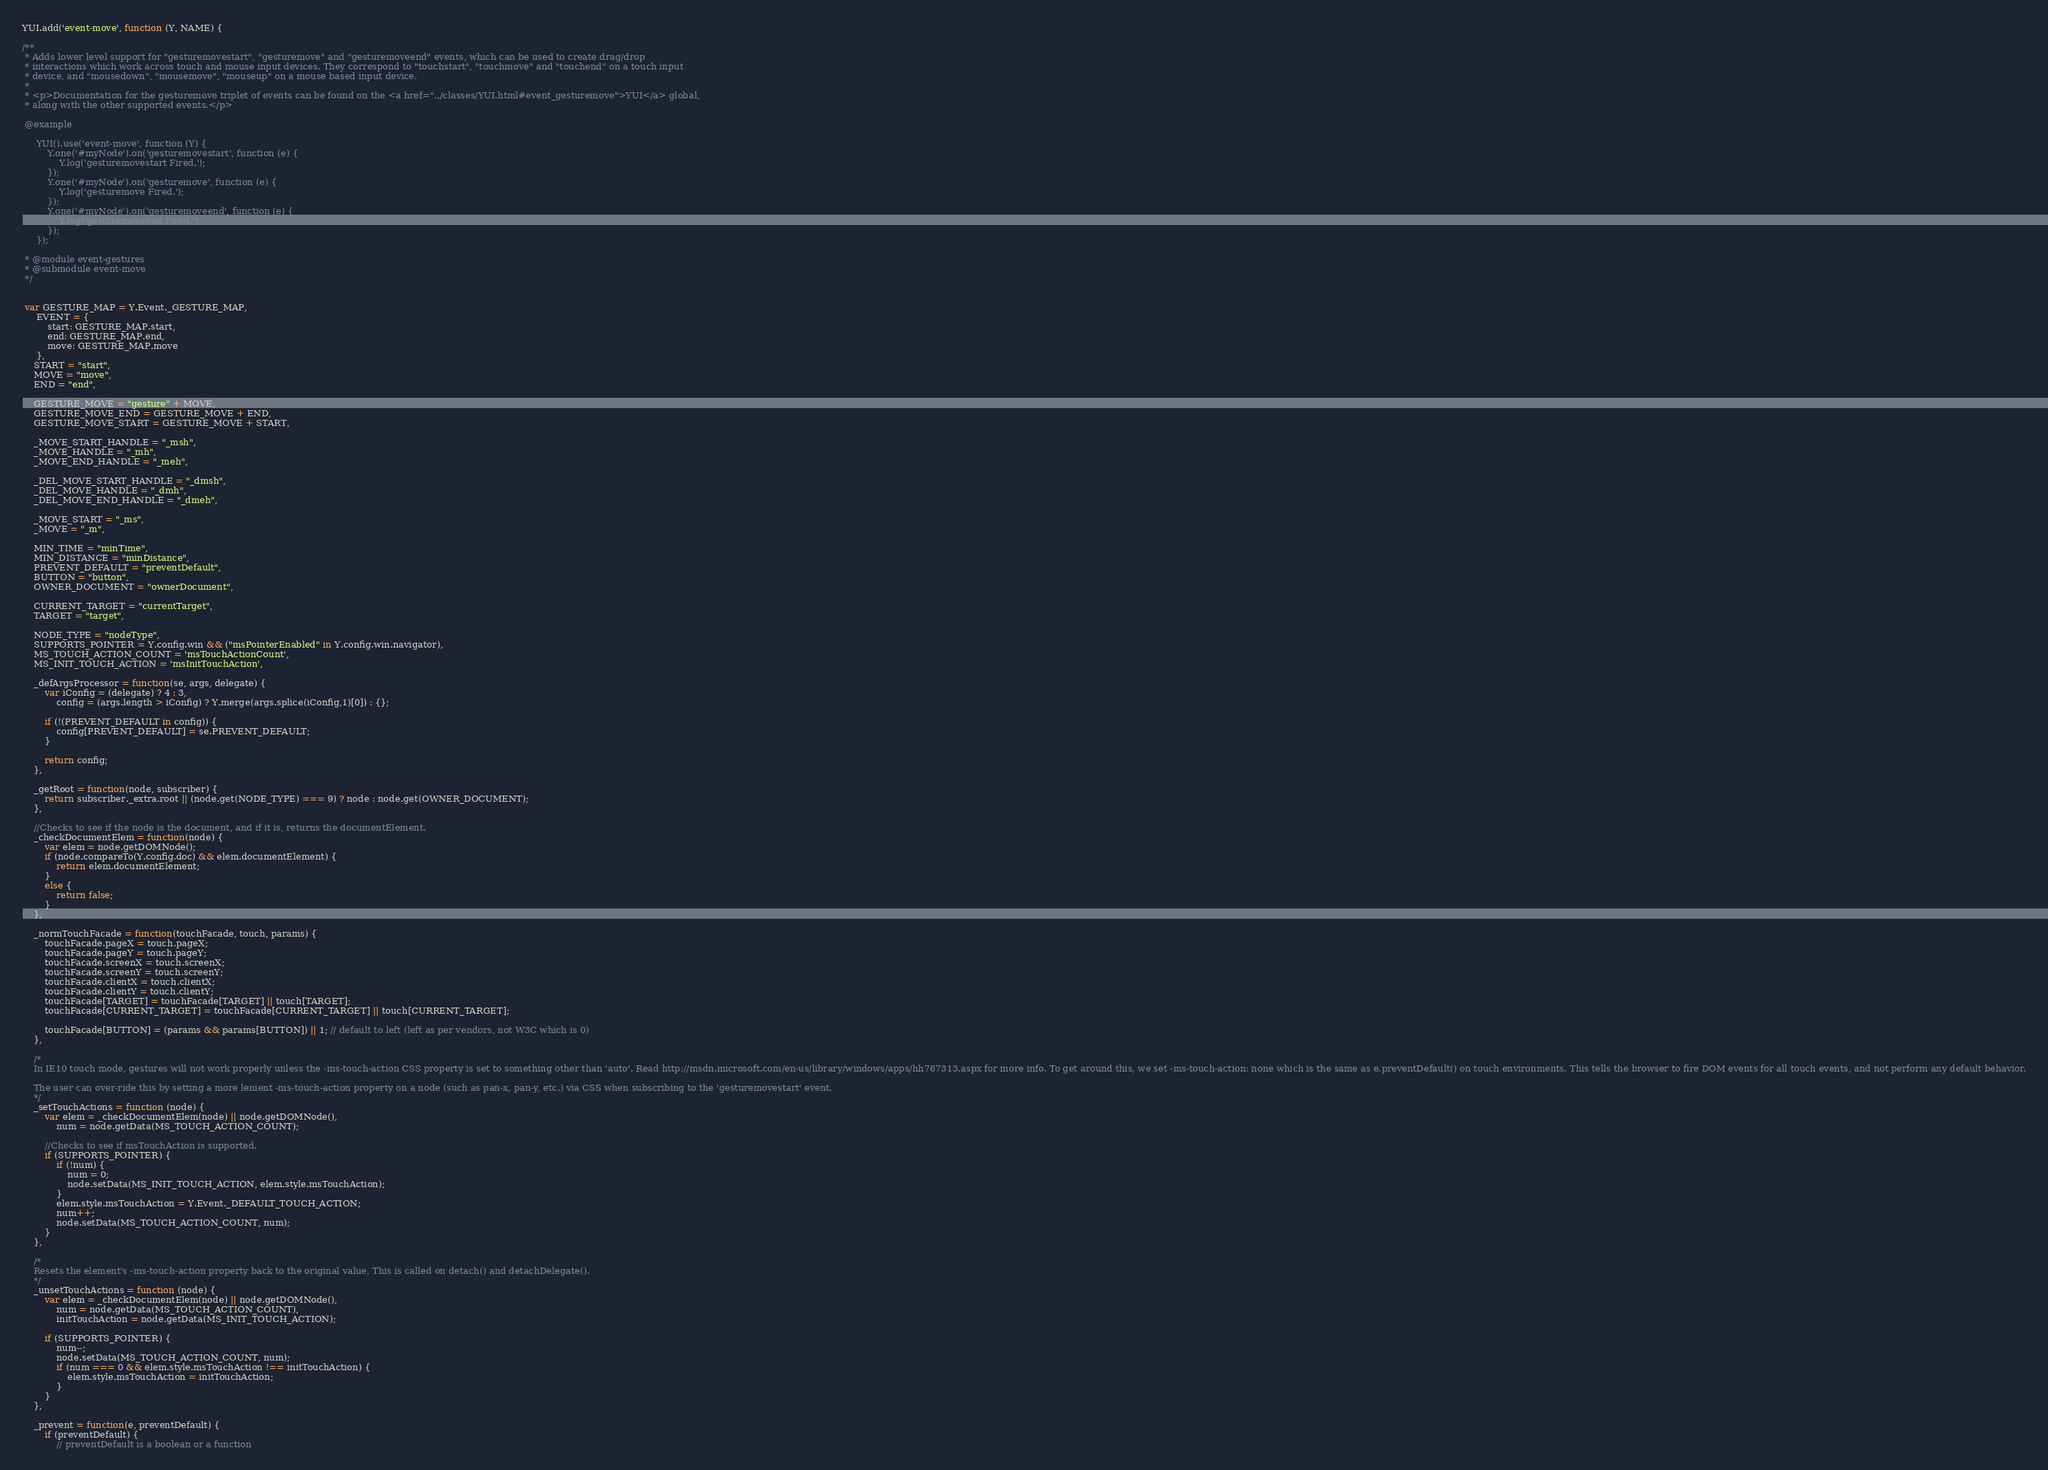<code> <loc_0><loc_0><loc_500><loc_500><_JavaScript_>YUI.add('event-move', function (Y, NAME) {

/**
 * Adds lower level support for "gesturemovestart", "gesturemove" and "gesturemoveend" events, which can be used to create drag/drop
 * interactions which work across touch and mouse input devices. They correspond to "touchstart", "touchmove" and "touchend" on a touch input
 * device, and "mousedown", "mousemove", "mouseup" on a mouse based input device.
 *
 * <p>Documentation for the gesturemove triplet of events can be found on the <a href="../classes/YUI.html#event_gesturemove">YUI</a> global,
 * along with the other supported events.</p>

 @example

     YUI().use('event-move', function (Y) {
         Y.one('#myNode').on('gesturemovestart', function (e) {
             Y.log('gesturemovestart Fired.');
         });
         Y.one('#myNode').on('gesturemove', function (e) {
             Y.log('gesturemove Fired.');
         });
         Y.one('#myNode').on('gesturemoveend', function (e) {
             Y.log('gesturemoveend Fired.');
         });
     });

 * @module event-gestures
 * @submodule event-move
 */


 var GESTURE_MAP = Y.Event._GESTURE_MAP,
     EVENT = {
         start: GESTURE_MAP.start,
         end: GESTURE_MAP.end,
         move: GESTURE_MAP.move
     },
    START = "start",
    MOVE = "move",
    END = "end",

    GESTURE_MOVE = "gesture" + MOVE,
    GESTURE_MOVE_END = GESTURE_MOVE + END,
    GESTURE_MOVE_START = GESTURE_MOVE + START,

    _MOVE_START_HANDLE = "_msh",
    _MOVE_HANDLE = "_mh",
    _MOVE_END_HANDLE = "_meh",

    _DEL_MOVE_START_HANDLE = "_dmsh",
    _DEL_MOVE_HANDLE = "_dmh",
    _DEL_MOVE_END_HANDLE = "_dmeh",

    _MOVE_START = "_ms",
    _MOVE = "_m",

    MIN_TIME = "minTime",
    MIN_DISTANCE = "minDistance",
    PREVENT_DEFAULT = "preventDefault",
    BUTTON = "button",
    OWNER_DOCUMENT = "ownerDocument",

    CURRENT_TARGET = "currentTarget",
    TARGET = "target",

    NODE_TYPE = "nodeType",
    SUPPORTS_POINTER = Y.config.win && ("msPointerEnabled" in Y.config.win.navigator),
    MS_TOUCH_ACTION_COUNT = 'msTouchActionCount',
    MS_INIT_TOUCH_ACTION = 'msInitTouchAction',

    _defArgsProcessor = function(se, args, delegate) {
        var iConfig = (delegate) ? 4 : 3,
            config = (args.length > iConfig) ? Y.merge(args.splice(iConfig,1)[0]) : {};

        if (!(PREVENT_DEFAULT in config)) {
            config[PREVENT_DEFAULT] = se.PREVENT_DEFAULT;
        }

        return config;
    },

    _getRoot = function(node, subscriber) {
        return subscriber._extra.root || (node.get(NODE_TYPE) === 9) ? node : node.get(OWNER_DOCUMENT);
    },

    //Checks to see if the node is the document, and if it is, returns the documentElement.
    _checkDocumentElem = function(node) {
        var elem = node.getDOMNode();
        if (node.compareTo(Y.config.doc) && elem.documentElement) {
            return elem.documentElement;
        }
        else {
            return false;
        }
    },

    _normTouchFacade = function(touchFacade, touch, params) {
        touchFacade.pageX = touch.pageX;
        touchFacade.pageY = touch.pageY;
        touchFacade.screenX = touch.screenX;
        touchFacade.screenY = touch.screenY;
        touchFacade.clientX = touch.clientX;
        touchFacade.clientY = touch.clientY;
        touchFacade[TARGET] = touchFacade[TARGET] || touch[TARGET];
        touchFacade[CURRENT_TARGET] = touchFacade[CURRENT_TARGET] || touch[CURRENT_TARGET];

        touchFacade[BUTTON] = (params && params[BUTTON]) || 1; // default to left (left as per vendors, not W3C which is 0)
    },

    /*
    In IE10 touch mode, gestures will not work properly unless the -ms-touch-action CSS property is set to something other than 'auto'. Read http://msdn.microsoft.com/en-us/library/windows/apps/hh767313.aspx for more info. To get around this, we set -ms-touch-action: none which is the same as e.preventDefault() on touch environments. This tells the browser to fire DOM events for all touch events, and not perform any default behavior.

    The user can over-ride this by setting a more lenient -ms-touch-action property on a node (such as pan-x, pan-y, etc.) via CSS when subscribing to the 'gesturemovestart' event.
    */
    _setTouchActions = function (node) {
        var elem = _checkDocumentElem(node) || node.getDOMNode(),
            num = node.getData(MS_TOUCH_ACTION_COUNT);

        //Checks to see if msTouchAction is supported.
        if (SUPPORTS_POINTER) {
            if (!num) {
                num = 0;
                node.setData(MS_INIT_TOUCH_ACTION, elem.style.msTouchAction);
            }
            elem.style.msTouchAction = Y.Event._DEFAULT_TOUCH_ACTION;
            num++;
            node.setData(MS_TOUCH_ACTION_COUNT, num);
        }
    },

    /*
    Resets the element's -ms-touch-action property back to the original value, This is called on detach() and detachDelegate().
    */
    _unsetTouchActions = function (node) {
        var elem = _checkDocumentElem(node) || node.getDOMNode(),
            num = node.getData(MS_TOUCH_ACTION_COUNT),
            initTouchAction = node.getData(MS_INIT_TOUCH_ACTION);

        if (SUPPORTS_POINTER) {
            num--;
            node.setData(MS_TOUCH_ACTION_COUNT, num);
            if (num === 0 && elem.style.msTouchAction !== initTouchAction) {
                elem.style.msTouchAction = initTouchAction;
            }
        }
    },

    _prevent = function(e, preventDefault) {
        if (preventDefault) {
            // preventDefault is a boolean or a function</code> 